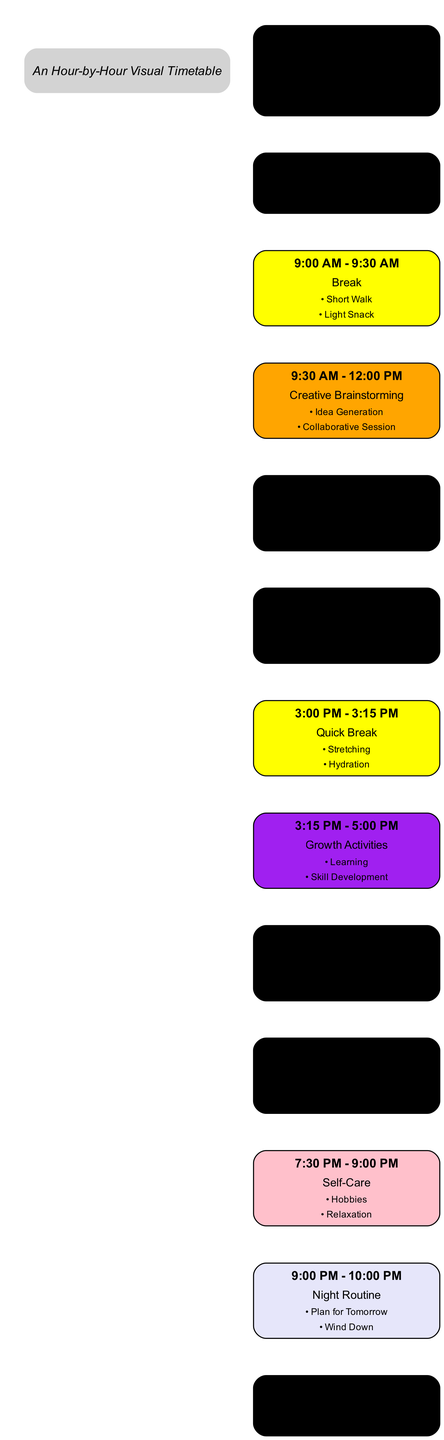What is the first activity in the timetable? The first time block listed in the diagram is from 6:00 AM to 7:00 AM, where the activity is "Morning Routine." This includes visible elements such as Meditation, Exercise, and Healthy Breakfast.
Answer: Morning Routine What color represents the "Focused Work Session"? The time blocks for "Focused Work Session," which occur from 7:00 AM to 9:00 AM and 1:00 PM to 3:00 PM, are both represented using the color "Sky Blue."
Answer: Sky Blue How long does the "Creative Brainstorming" session last? The "Creative Brainstorming" session is scheduled from 9:30 AM to 12:00 PM, indicating a duration of 2 hours and 30 minutes. The length can be confirmed by looking at the start and end times.
Answer: 2 hours 30 minutes What activities are included in the "Self-Care" block? The "Self-Care" block runs from 7:30 PM to 9:00 PM, and it includes two activities: Hobbies and Relaxation, both of which promote personal well-being after a productive day.
Answer: Hobbies, Relaxation Which time block has the shortest duration? The "Quick Break" from 3:00 PM to 3:15 PM only lasts for 15 minutes, making it the shortest block in the timetable.
Answer: 15 minutes What is the last activity of the day? The last activity listed in the diagram is the "Night Routine," which occurs from 9:00 PM to 10:00 PM, aimed at winding down before sleep.
Answer: Night Routine How many color-coded activities are scheduled before lunch? There are four activities scheduled before lunch, identified as Morning Routine, Focused Work Session, Break, and Creative Brainstorming. Each is color-coded as per their respective time blocks.
Answer: 4 activities What is the focus of the "Growth Activities" block? The "Growth Activities" block consists of Learning and Skill Development, which are centered around personal and professional growth through reading and practice.
Answer: Learning, Skill Development 